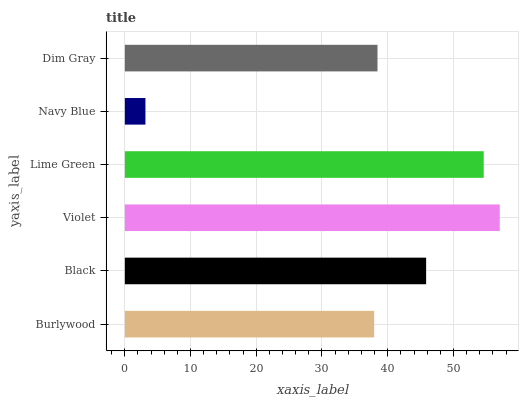Is Navy Blue the minimum?
Answer yes or no. Yes. Is Violet the maximum?
Answer yes or no. Yes. Is Black the minimum?
Answer yes or no. No. Is Black the maximum?
Answer yes or no. No. Is Black greater than Burlywood?
Answer yes or no. Yes. Is Burlywood less than Black?
Answer yes or no. Yes. Is Burlywood greater than Black?
Answer yes or no. No. Is Black less than Burlywood?
Answer yes or no. No. Is Black the high median?
Answer yes or no. Yes. Is Dim Gray the low median?
Answer yes or no. Yes. Is Navy Blue the high median?
Answer yes or no. No. Is Violet the low median?
Answer yes or no. No. 